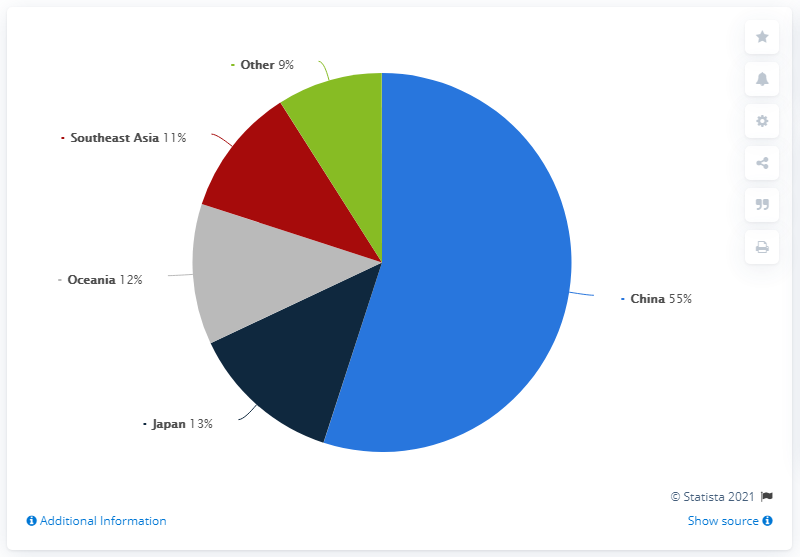How does the 12% market share of Oceania compare to its population size? Oceania's 12% market share is relatively significant when considering its smaller population size compared to other regions like China or Southeast Asia. This suggests a high per capita consumption or investment in this market, indicating a prosperous economic sector relative to population. Could the high market share be indicative of certain industries or products being more popular in Oceania? Indeed, the substantial market share could suggest higher sales or demand for specific industries such as technology, tourism, or commodities native to Oceania. Analyzing which sectors lead this market share could provide deeper insights into consumer behavior and economic strategies within the region. 